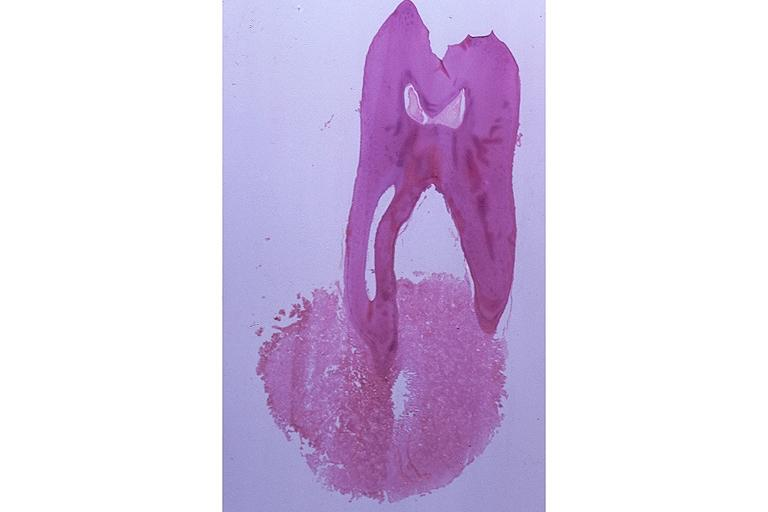what does this image show?
Answer the question using a single word or phrase. Cementoblastoma 